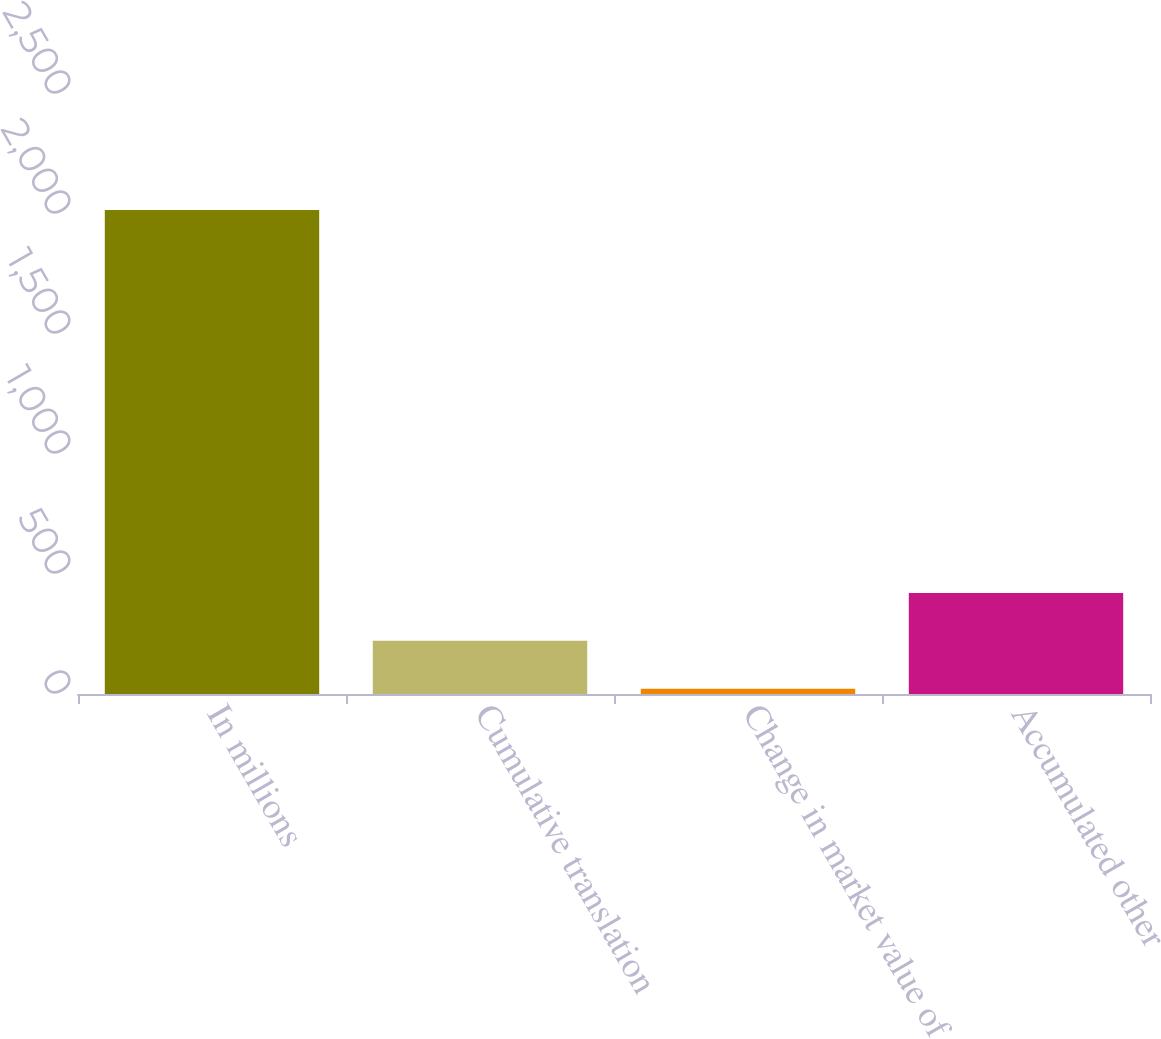Convert chart to OTSL. <chart><loc_0><loc_0><loc_500><loc_500><bar_chart><fcel>In millions<fcel>Cumulative translation<fcel>Change in market value of<fcel>Accumulated other<nl><fcel>2017<fcel>221.5<fcel>22<fcel>421<nl></chart> 